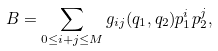<formula> <loc_0><loc_0><loc_500><loc_500>B = \sum _ { 0 \leq i + j \leq M } g _ { i j } ( q _ { 1 } , q _ { 2 } ) p _ { 1 } ^ { i } p _ { 2 } ^ { j } ,</formula> 